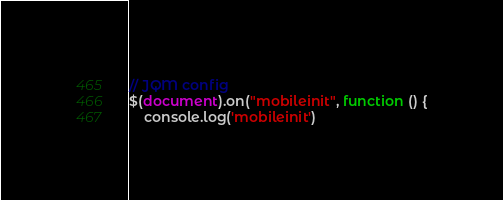<code> <loc_0><loc_0><loc_500><loc_500><_JavaScript_>// JQM config
$(document).on("mobileinit", function () {
    console.log('mobileinit')</code> 